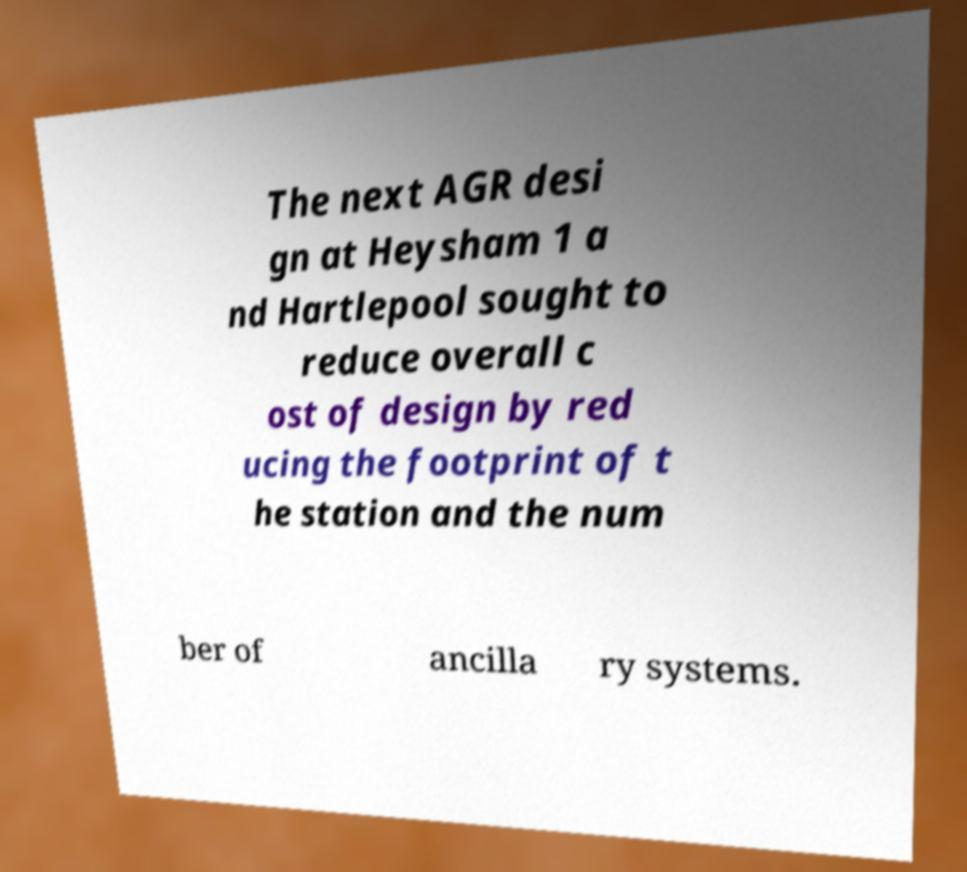I need the written content from this picture converted into text. Can you do that? The next AGR desi gn at Heysham 1 a nd Hartlepool sought to reduce overall c ost of design by red ucing the footprint of t he station and the num ber of ancilla ry systems. 